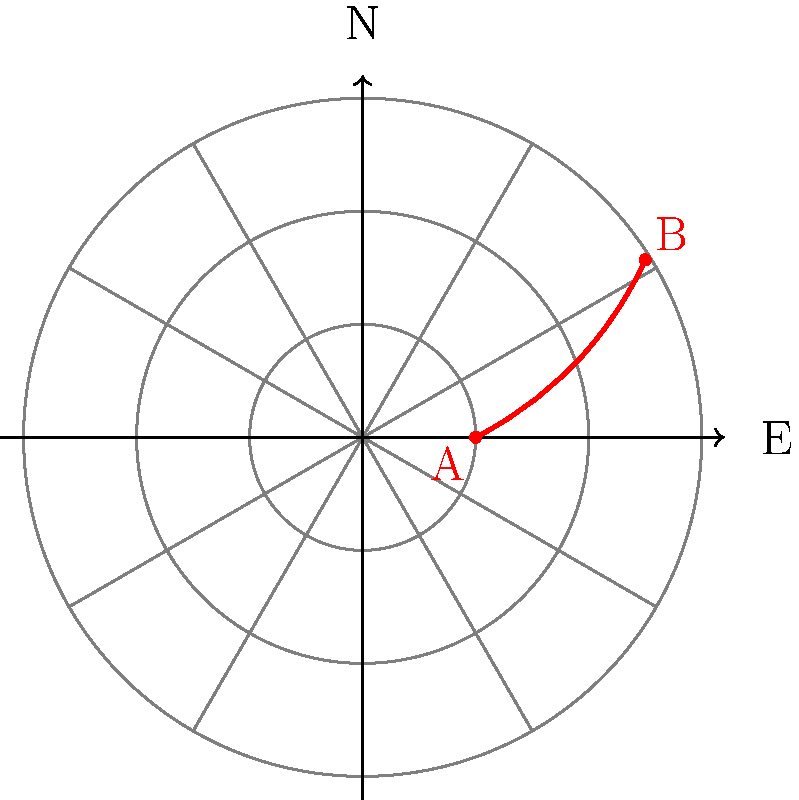A hurricane's trajectory is plotted on a polar coordinate system, where the radial distance represents the storm's intensity (in arbitrary units) and the angle represents its direction from due east. The storm begins at point A (1, 0°) and ends at point B (2.5, 90°). If the storm's intensity increases linearly with time, what is the storm's intensity when it is moving in a northeasterly direction (45°)? To solve this problem, we need to follow these steps:

1) First, we identify the start and end points:
   A: $(r_1, \theta_1) = (1, 0°)$
   B: $(r_2, \theta_2) = (2.5, 90°)$

2) We're asked about the point where $\theta = 45°$. Let's call this point C $(r_3, 45°)$.

3) Since the intensity increases linearly with time, and we assume the angular velocity is constant, we can use linear interpolation:

   $r_3 = r_1 + \frac{\theta_3 - \theta_1}{\theta_2 - \theta_1} (r_2 - r_1)$

4) Substituting the values:
   
   $r_3 = 1 + \frac{45° - 0°}{90° - 0°} (2.5 - 1)$

5) Simplifying:
   
   $r_3 = 1 + \frac{1}{2} (1.5) = 1 + 0.75 = 1.75$

Therefore, when the hurricane is moving northeast (45°), its intensity is 1.75 units.
Answer: 1.75 units 